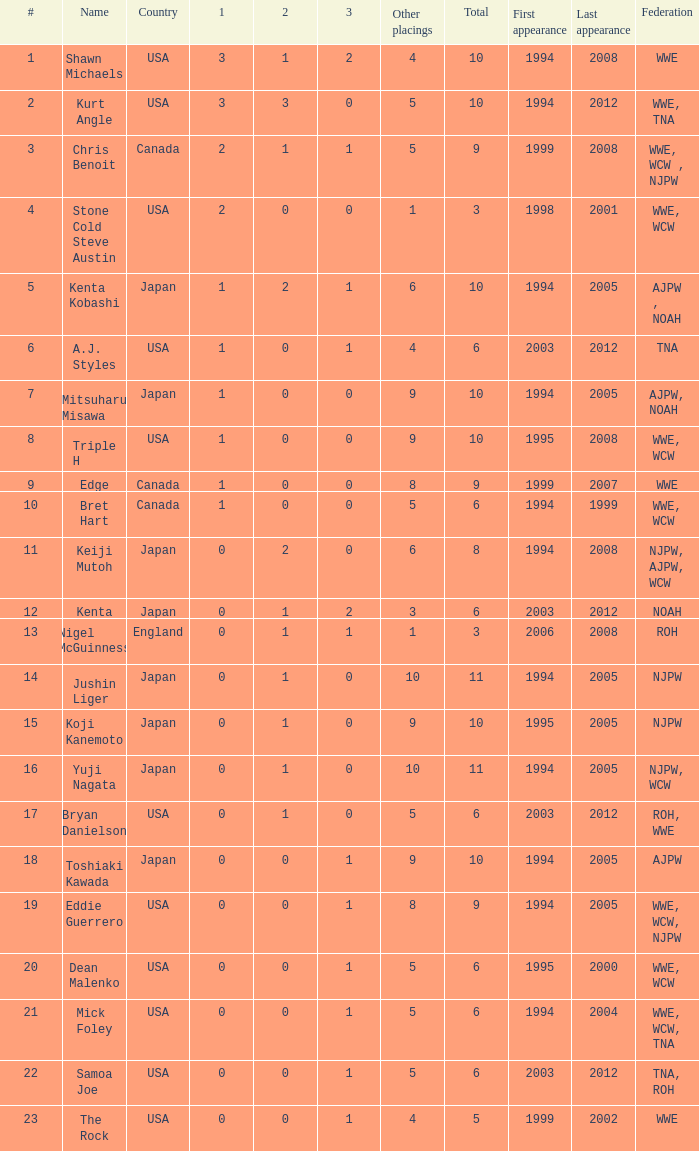How many instances are there of a wrestler from roh, wwe competing in this event? 1.0. 